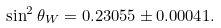Convert formula to latex. <formula><loc_0><loc_0><loc_500><loc_500>\sin ^ { 2 } \theta _ { W } = 0 . 2 3 0 5 5 \pm 0 . 0 0 0 4 1 .</formula> 